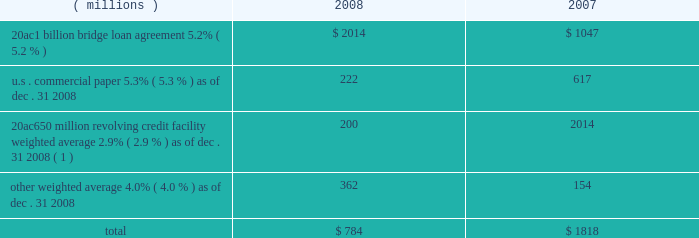Notes to the consolidated financial statements on march 18 , 2008 , ppg completed a public offering of $ 600 million in aggregate principal amount of its 5.75% ( 5.75 % ) notes due 2013 ( the 201c2013 notes 201d ) , $ 700 million in aggregate principal amount of its 6.65% ( 6.65 % ) notes due 2018 ( the 201c2018 notes 201d ) and $ 250 million in aggregate principal amount of its 7.70% ( 7.70 % ) notes due 2038 ( the 201c2038 notes 201d and , together with the 2013 notes and the 2018 notes , the 201cnotes 201d ) .
The notes were offered by the company pursuant to its existing shelf registration .
The proceeds of this offering of $ 1538 million ( net of discount and issuance costs ) and additional borrowings of $ 195 million under the 20ac650 million revolving credit facility were used to repay existing debt , including certain short-term debt and the amounts outstanding under the 20ac1 billion bridge loan .
No further amounts can be borrowed under the 20ac1 billion bridge loan .
The discount and issuance costs related to the notes , which totaled $ 12 million , will be amortized to interest expense over the respective lives of the notes .
Short-term debt outstanding as of december 31 , 2008 and 2007 , was as follows : ( millions ) 2008 2007 .
Total $ 784 $ 1818 ( 1 ) borrowings under this facility have a term of 30 days and can be rolled over monthly until the facility expires in 2010 .
Ppg is in compliance with the restrictive covenants under its various credit agreements , loan agreements and indentures .
The company 2019s revolving credit agreements include a financial ratio covenant .
The covenant requires that the amount of total indebtedness not exceed 60% ( 60 % ) of the company 2019s total capitalization excluding the portion of accumulated other comprehensive income ( loss ) related to pensions and other postretirement benefit adjustments .
As of december 31 , 2008 , total indebtedness was 45% ( 45 % ) of the company 2019s total capitalization excluding the portion of accumulated other comprehensive income ( loss ) related to pensions and other postretirement benefit adjustments .
Additionally , substantially all of the company 2019s debt agreements contain customary cross- default provisions .
Those provisions generally provide that a default on a debt service payment of $ 10 million or more for longer than the grace period provided ( usually 10 days ) under one agreement may result in an event of default under other agreements .
None of the company 2019s primary debt obligations are secured or guaranteed by the company 2019s affiliates .
Interest payments in 2008 , 2007 and 2006 totaled $ 228 million , $ 102 million and $ 90 million , respectively .
Rental expense for operating leases was $ 267 million , $ 188 million and $ 161 million in 2008 , 2007 and 2006 , respectively .
The primary leased assets include paint stores , transportation equipment , warehouses and other distribution facilities , and office space , including the company 2019s corporate headquarters located in pittsburgh , pa .
Minimum lease commitments for operating leases that have initial or remaining lease terms in excess of one year as of december 31 , 2008 , are ( in millions ) $ 126 in 2009 , $ 107 in 2010 , $ 82 in 2011 , $ 65 in 2012 , $ 51 in 2013 and $ 202 thereafter .
The company had outstanding letters of credit of $ 82 million as of december 31 , 2008 .
The letters of credit secure the company 2019s performance to third parties under certain self-insurance programs and other commitments made in the ordinary course of business .
As of december 31 , 2008 and 2007 guarantees outstanding were $ 70 million .
The guarantees relate primarily to debt of certain entities in which ppg has an ownership interest and selected customers of certain of the company 2019s businesses .
A portion of such debt is secured by the assets of the related entities .
The carrying values of these guarantees were $ 9 million and $ 3 million as of december 31 , 2008 and 2007 , respectively , and the fair values were $ 40 million and $ 17 million , as of december 31 , 2008 and 2007 , respectively .
The company does not believe any loss related to these letters of credit or guarantees is likely .
10 .
Financial instruments , excluding derivative financial instruments included in ppg 2019s financial instrument portfolio are cash and cash equivalents , cash held in escrow , marketable equity securities , company-owned life insurance and short- and long-term debt instruments .
The fair values of the financial instruments approximated their carrying values , in the aggregate , except for long-term long-term debt ( excluding capital lease obligations ) , had carrying and fair values totaling $ 3122 million and $ 3035 million , respectively , as of december 31 , 2008 .
The corresponding amounts as of december 31 , 2007 , were $ 1201 million and $ 1226 million , respectively .
The fair values of the debt instruments were based on discounted cash flows and interest rates currently available to the company for instruments of the same remaining maturities .
2008 ppg annual report and form 10-k 45 .
What was the percentage change in interest payments from 2006 to 2007? 
Computations: ((102 - 90) / 90)
Answer: 0.13333. 